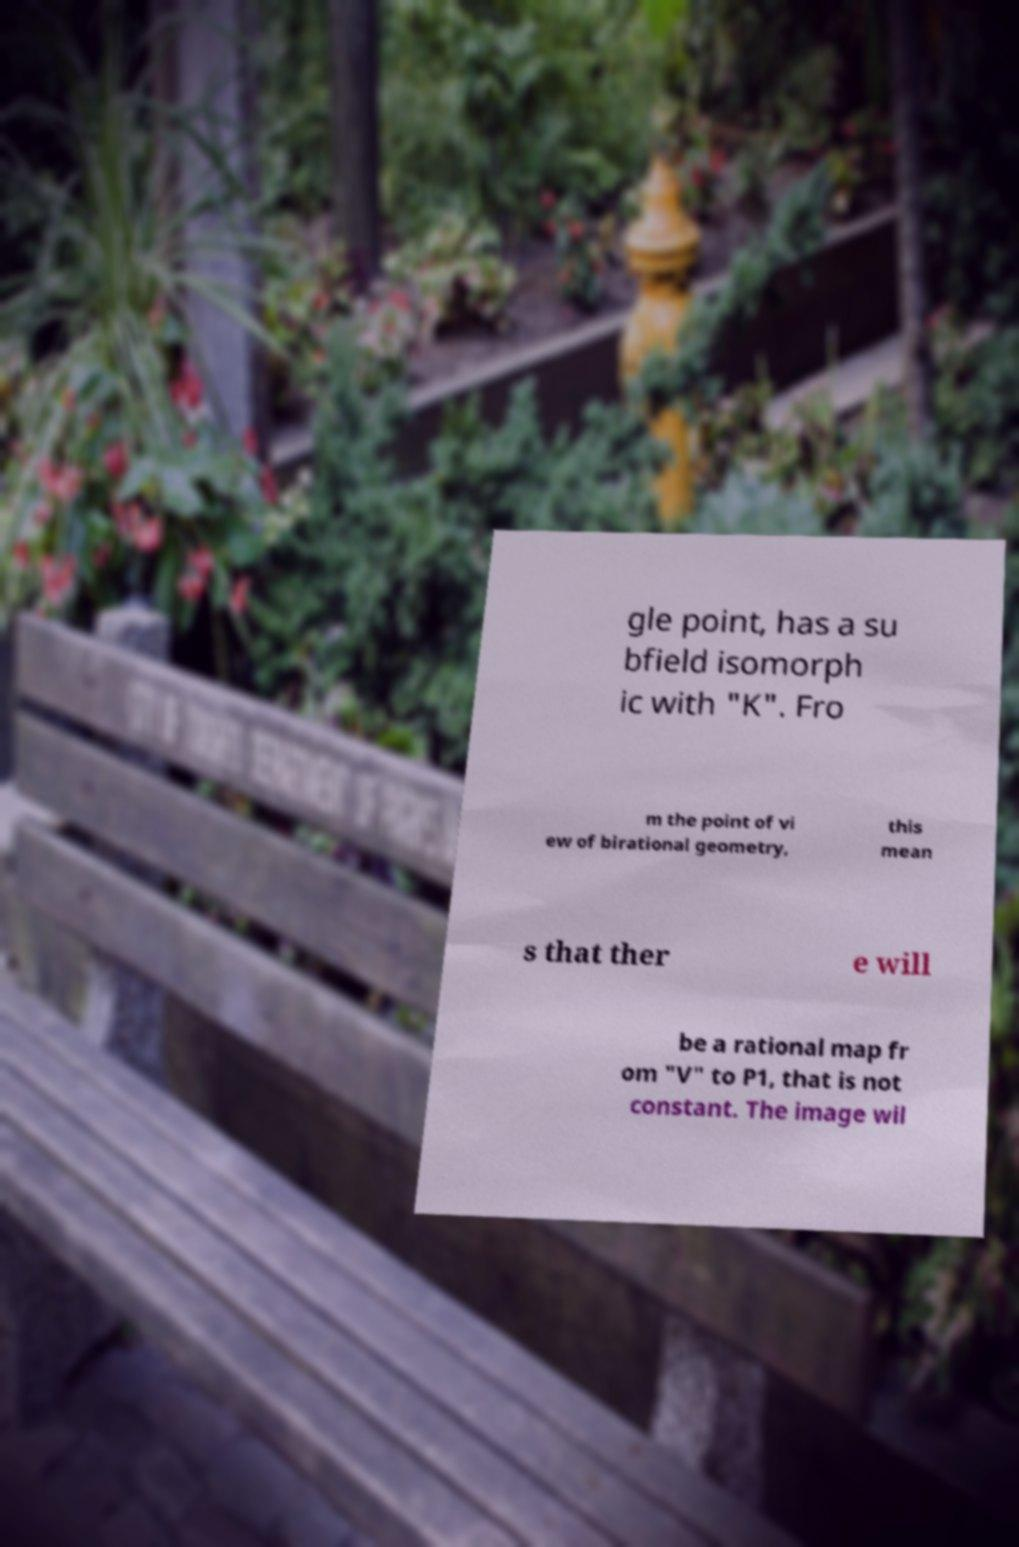There's text embedded in this image that I need extracted. Can you transcribe it verbatim? gle point, has a su bfield isomorph ic with "K". Fro m the point of vi ew of birational geometry, this mean s that ther e will be a rational map fr om "V" to P1, that is not constant. The image wil 